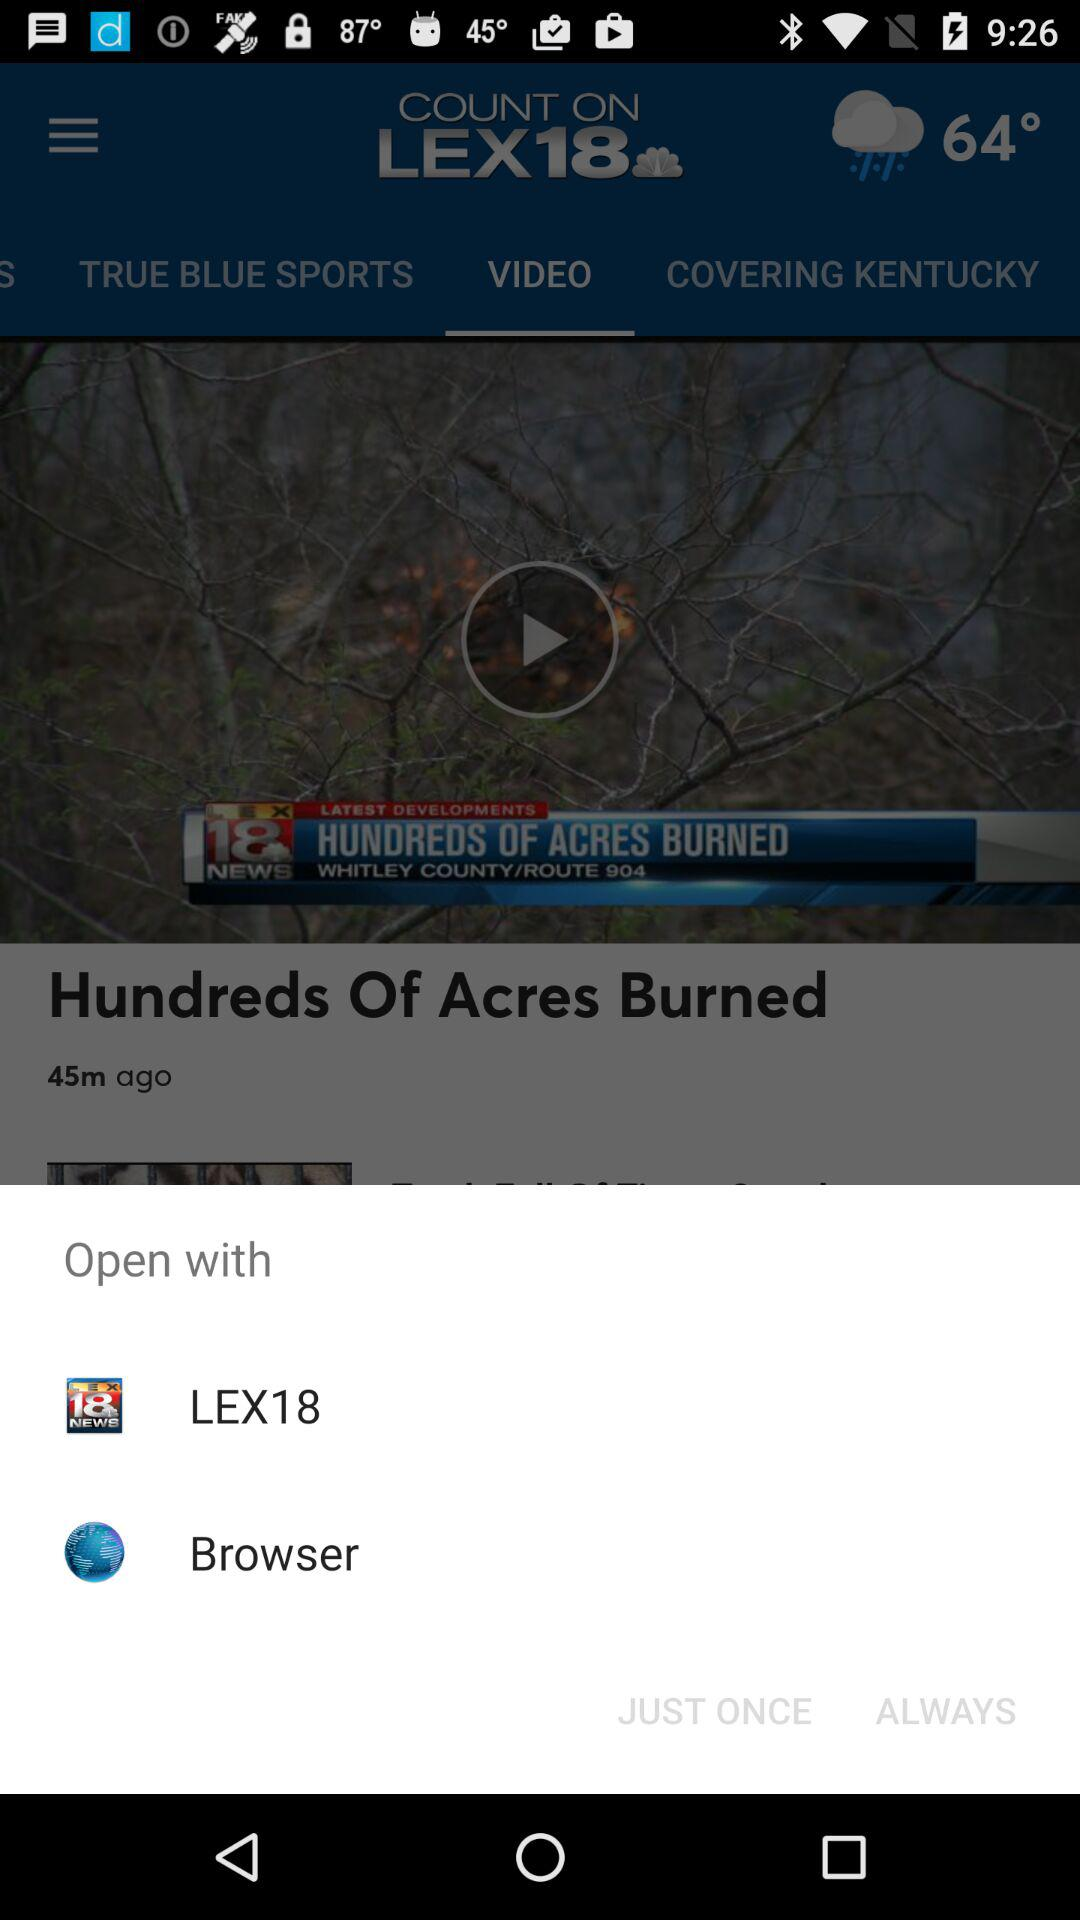Which application can I use to open the content? You can use "LEX18" to open the content. 